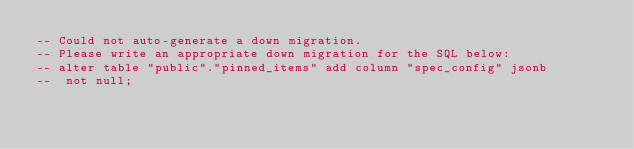Convert code to text. <code><loc_0><loc_0><loc_500><loc_500><_SQL_>-- Could not auto-generate a down migration.
-- Please write an appropriate down migration for the SQL below:
-- alter table "public"."pinned_items" add column "spec_config" jsonb
--  not null;
</code> 